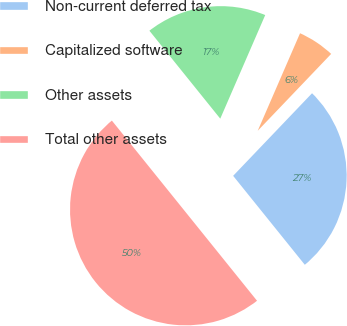<chart> <loc_0><loc_0><loc_500><loc_500><pie_chart><fcel>Non-current deferred tax<fcel>Capitalized software<fcel>Other assets<fcel>Total other assets<nl><fcel>27.07%<fcel>5.62%<fcel>17.31%<fcel>50.0%<nl></chart> 